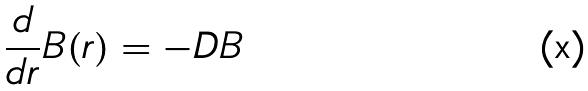<formula> <loc_0><loc_0><loc_500><loc_500>\frac { d } { d r } B ( r ) = - D B</formula> 